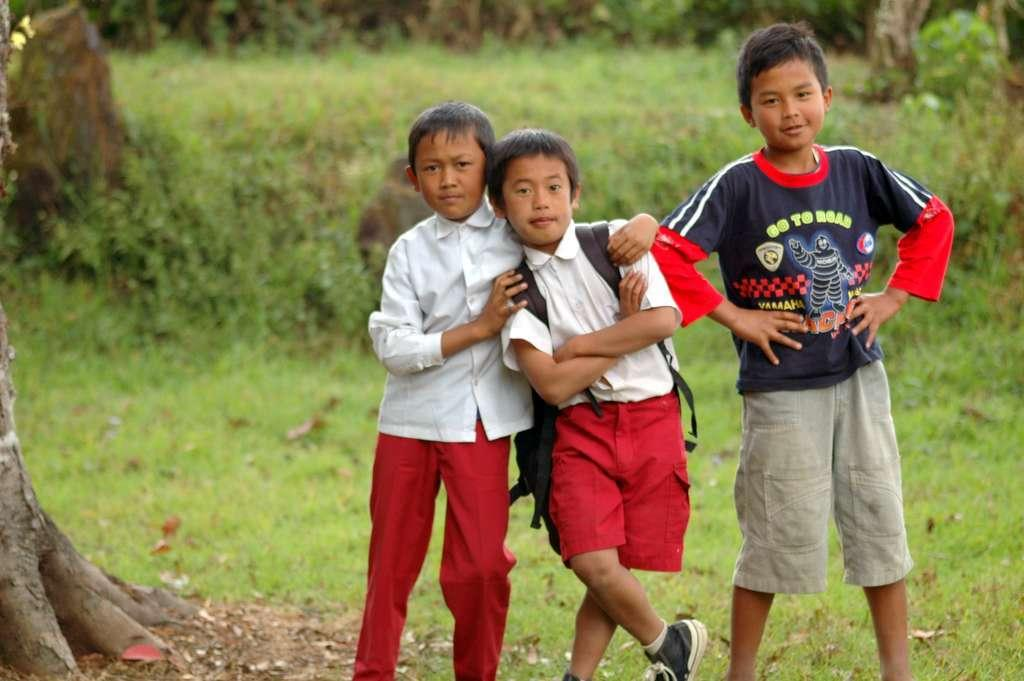How many kids are in the image? There are three kids in the image. Can you describe what one of the kids is carrying? One of the kids is carrying a backpack. What type of natural environment is visible at the bottom of the image? There is grass and some plants at the bottom of the image. Where is the tree located in the image? The tree is on the left side of the image. What type of plot is the tree growing on in the image? There is no indication of a plot or any type of land feature in the image; it simply shows a tree on the left side. Can you describe the twig that the kids are using to play with in the image? There is no twig or any object being used by the kids to play with in the image. 